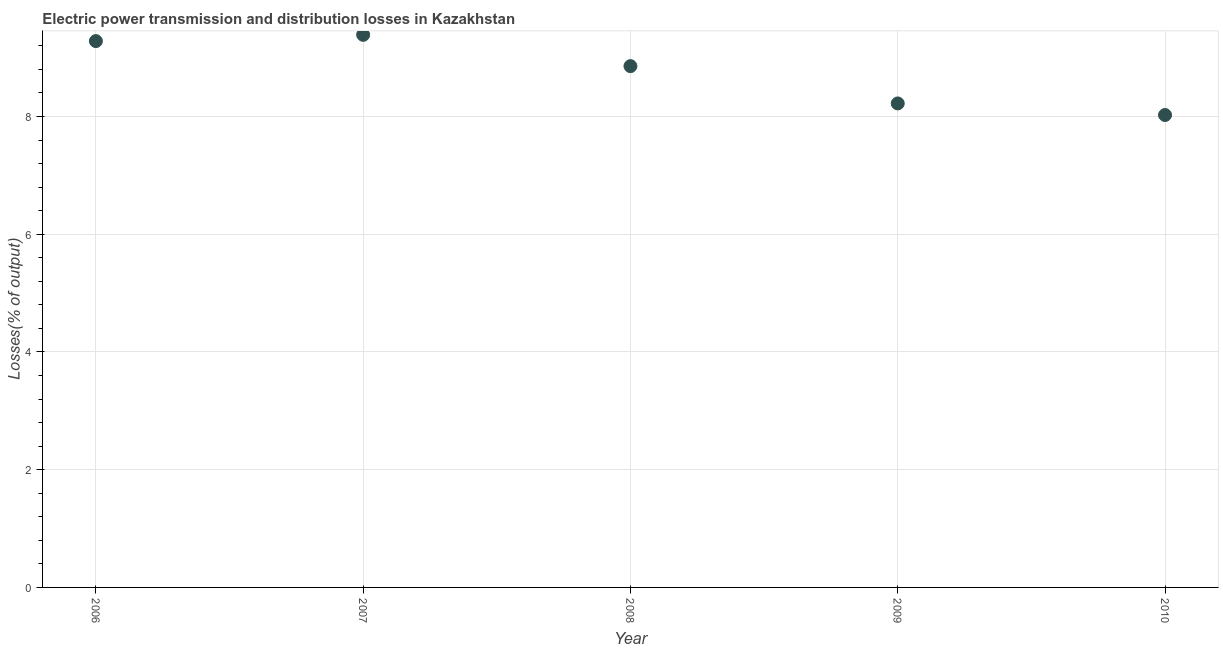What is the electric power transmission and distribution losses in 2008?
Offer a very short reply. 8.86. Across all years, what is the maximum electric power transmission and distribution losses?
Offer a very short reply. 9.39. Across all years, what is the minimum electric power transmission and distribution losses?
Give a very brief answer. 8.03. In which year was the electric power transmission and distribution losses minimum?
Give a very brief answer. 2010. What is the sum of the electric power transmission and distribution losses?
Ensure brevity in your answer.  43.77. What is the difference between the electric power transmission and distribution losses in 2006 and 2010?
Provide a short and direct response. 1.26. What is the average electric power transmission and distribution losses per year?
Keep it short and to the point. 8.75. What is the median electric power transmission and distribution losses?
Provide a short and direct response. 8.86. Do a majority of the years between 2007 and 2006 (inclusive) have electric power transmission and distribution losses greater than 6.4 %?
Your response must be concise. No. What is the ratio of the electric power transmission and distribution losses in 2007 to that in 2008?
Provide a short and direct response. 1.06. Is the difference between the electric power transmission and distribution losses in 2007 and 2009 greater than the difference between any two years?
Keep it short and to the point. No. What is the difference between the highest and the second highest electric power transmission and distribution losses?
Offer a very short reply. 0.11. Is the sum of the electric power transmission and distribution losses in 2007 and 2010 greater than the maximum electric power transmission and distribution losses across all years?
Give a very brief answer. Yes. What is the difference between the highest and the lowest electric power transmission and distribution losses?
Your answer should be very brief. 1.36. How many dotlines are there?
Provide a short and direct response. 1. Are the values on the major ticks of Y-axis written in scientific E-notation?
Your response must be concise. No. Does the graph contain any zero values?
Provide a succinct answer. No. Does the graph contain grids?
Provide a succinct answer. Yes. What is the title of the graph?
Make the answer very short. Electric power transmission and distribution losses in Kazakhstan. What is the label or title of the Y-axis?
Keep it short and to the point. Losses(% of output). What is the Losses(% of output) in 2006?
Provide a short and direct response. 9.28. What is the Losses(% of output) in 2007?
Provide a short and direct response. 9.39. What is the Losses(% of output) in 2008?
Your answer should be very brief. 8.86. What is the Losses(% of output) in 2009?
Offer a very short reply. 8.22. What is the Losses(% of output) in 2010?
Provide a succinct answer. 8.03. What is the difference between the Losses(% of output) in 2006 and 2007?
Your answer should be very brief. -0.11. What is the difference between the Losses(% of output) in 2006 and 2008?
Provide a succinct answer. 0.43. What is the difference between the Losses(% of output) in 2006 and 2009?
Keep it short and to the point. 1.06. What is the difference between the Losses(% of output) in 2006 and 2010?
Your answer should be very brief. 1.26. What is the difference between the Losses(% of output) in 2007 and 2008?
Keep it short and to the point. 0.53. What is the difference between the Losses(% of output) in 2007 and 2009?
Ensure brevity in your answer.  1.17. What is the difference between the Losses(% of output) in 2007 and 2010?
Offer a very short reply. 1.36. What is the difference between the Losses(% of output) in 2008 and 2009?
Your response must be concise. 0.63. What is the difference between the Losses(% of output) in 2008 and 2010?
Provide a short and direct response. 0.83. What is the difference between the Losses(% of output) in 2009 and 2010?
Keep it short and to the point. 0.2. What is the ratio of the Losses(% of output) in 2006 to that in 2007?
Keep it short and to the point. 0.99. What is the ratio of the Losses(% of output) in 2006 to that in 2008?
Your answer should be compact. 1.05. What is the ratio of the Losses(% of output) in 2006 to that in 2009?
Your response must be concise. 1.13. What is the ratio of the Losses(% of output) in 2006 to that in 2010?
Your response must be concise. 1.16. What is the ratio of the Losses(% of output) in 2007 to that in 2008?
Offer a terse response. 1.06. What is the ratio of the Losses(% of output) in 2007 to that in 2009?
Your answer should be very brief. 1.14. What is the ratio of the Losses(% of output) in 2007 to that in 2010?
Make the answer very short. 1.17. What is the ratio of the Losses(% of output) in 2008 to that in 2009?
Ensure brevity in your answer.  1.08. What is the ratio of the Losses(% of output) in 2008 to that in 2010?
Your answer should be very brief. 1.1. 